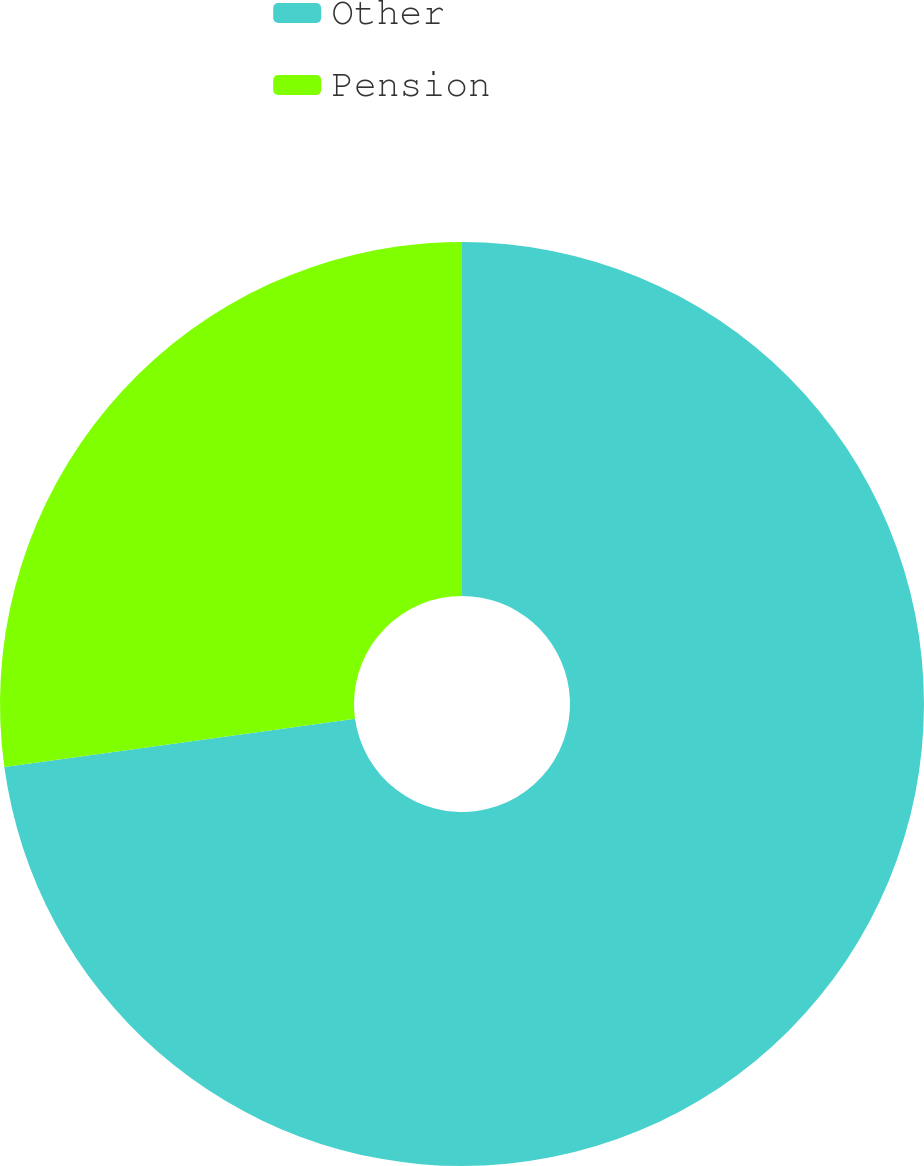Convert chart to OTSL. <chart><loc_0><loc_0><loc_500><loc_500><pie_chart><fcel>Other<fcel>Pension<nl><fcel>72.82%<fcel>27.18%<nl></chart> 